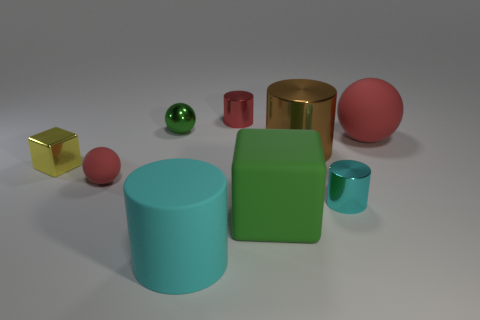Subtract all rubber spheres. How many spheres are left? 1 Subtract all red spheres. How many spheres are left? 1 Add 1 big brown cylinders. How many objects exist? 10 Subtract 2 blocks. How many blocks are left? 0 Subtract all cubes. How many objects are left? 7 Add 1 large spheres. How many large spheres are left? 2 Add 6 metallic cylinders. How many metallic cylinders exist? 9 Subtract 2 cyan cylinders. How many objects are left? 7 Subtract all brown cubes. Subtract all purple cylinders. How many cubes are left? 2 Subtract all green spheres. How many green cylinders are left? 0 